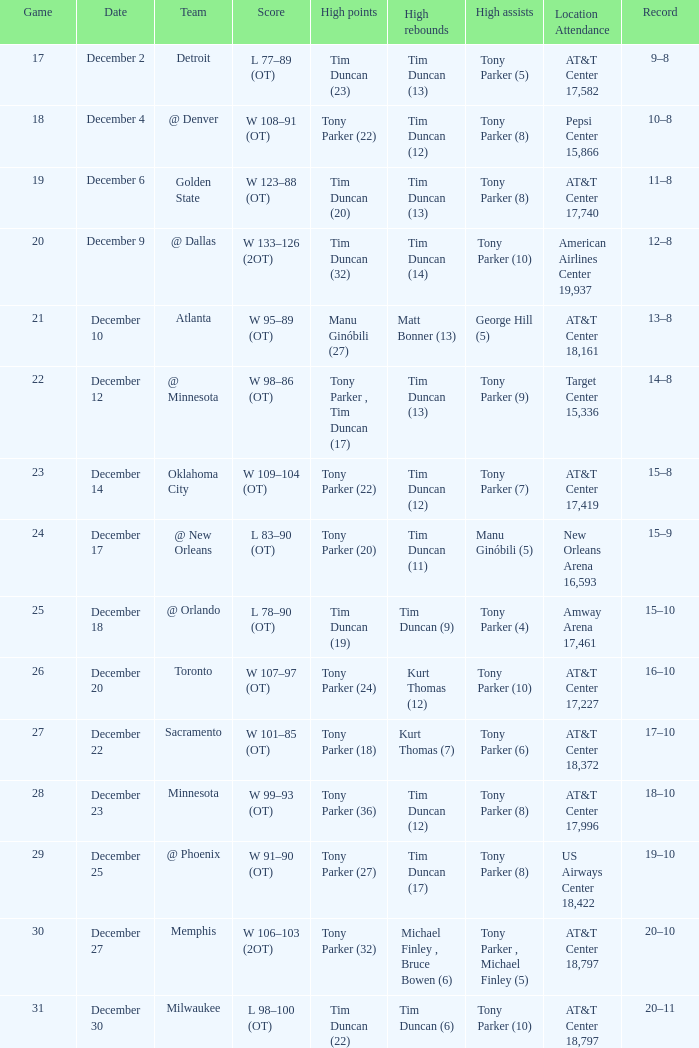What score has tim duncan (14) as the high rebounds? W 133–126 (2OT). 